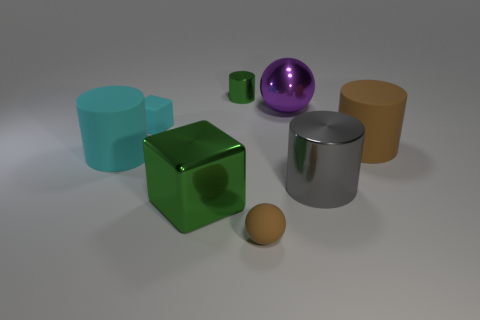Add 2 metallic cubes. How many objects exist? 10 Subtract all gray metallic cylinders. How many cylinders are left? 3 Subtract all purple spheres. How many spheres are left? 1 Subtract all balls. How many objects are left? 6 Subtract 1 cubes. How many cubes are left? 1 Subtract all small brown spheres. Subtract all small cyan spheres. How many objects are left? 7 Add 7 large rubber objects. How many large rubber objects are left? 9 Add 2 large cyan matte cylinders. How many large cyan matte cylinders exist? 3 Subtract 1 cyan cylinders. How many objects are left? 7 Subtract all cyan blocks. Subtract all purple balls. How many blocks are left? 1 